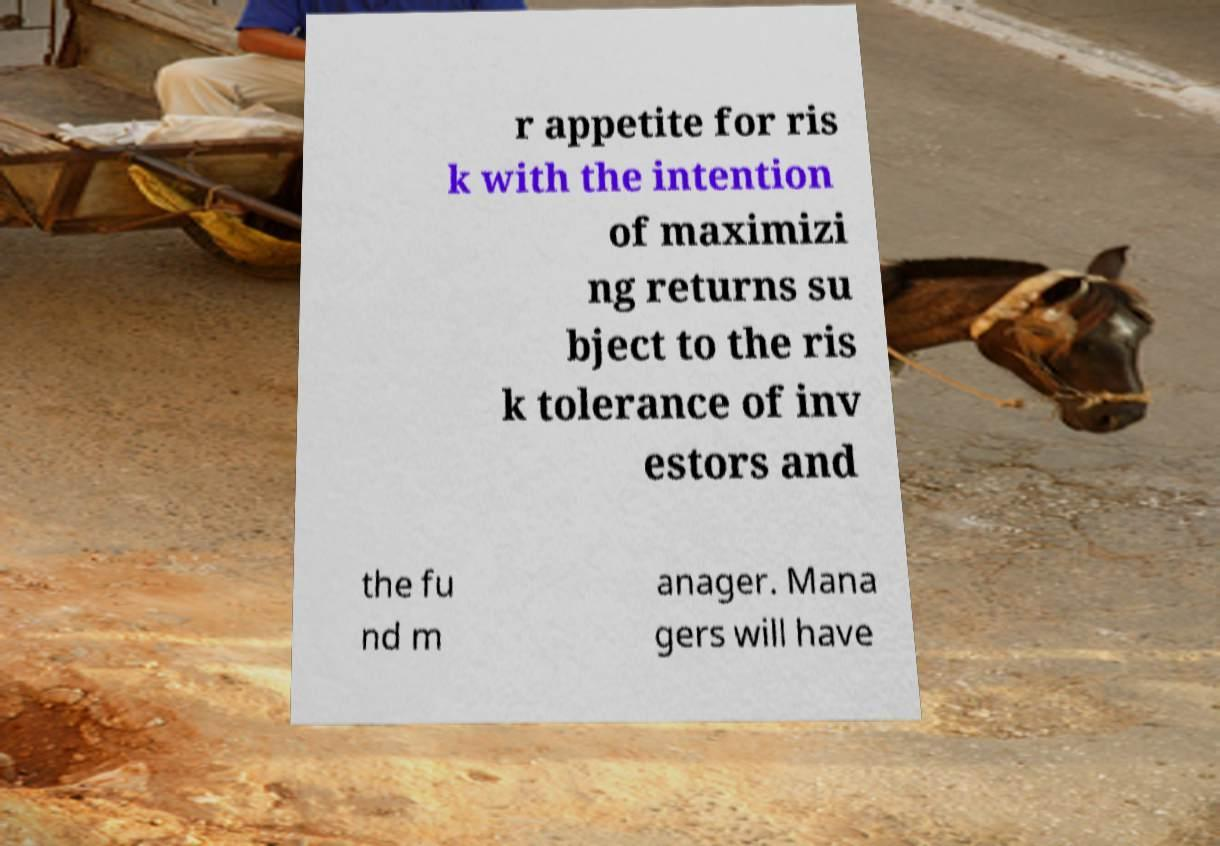There's text embedded in this image that I need extracted. Can you transcribe it verbatim? r appetite for ris k with the intention of maximizi ng returns su bject to the ris k tolerance of inv estors and the fu nd m anager. Mana gers will have 